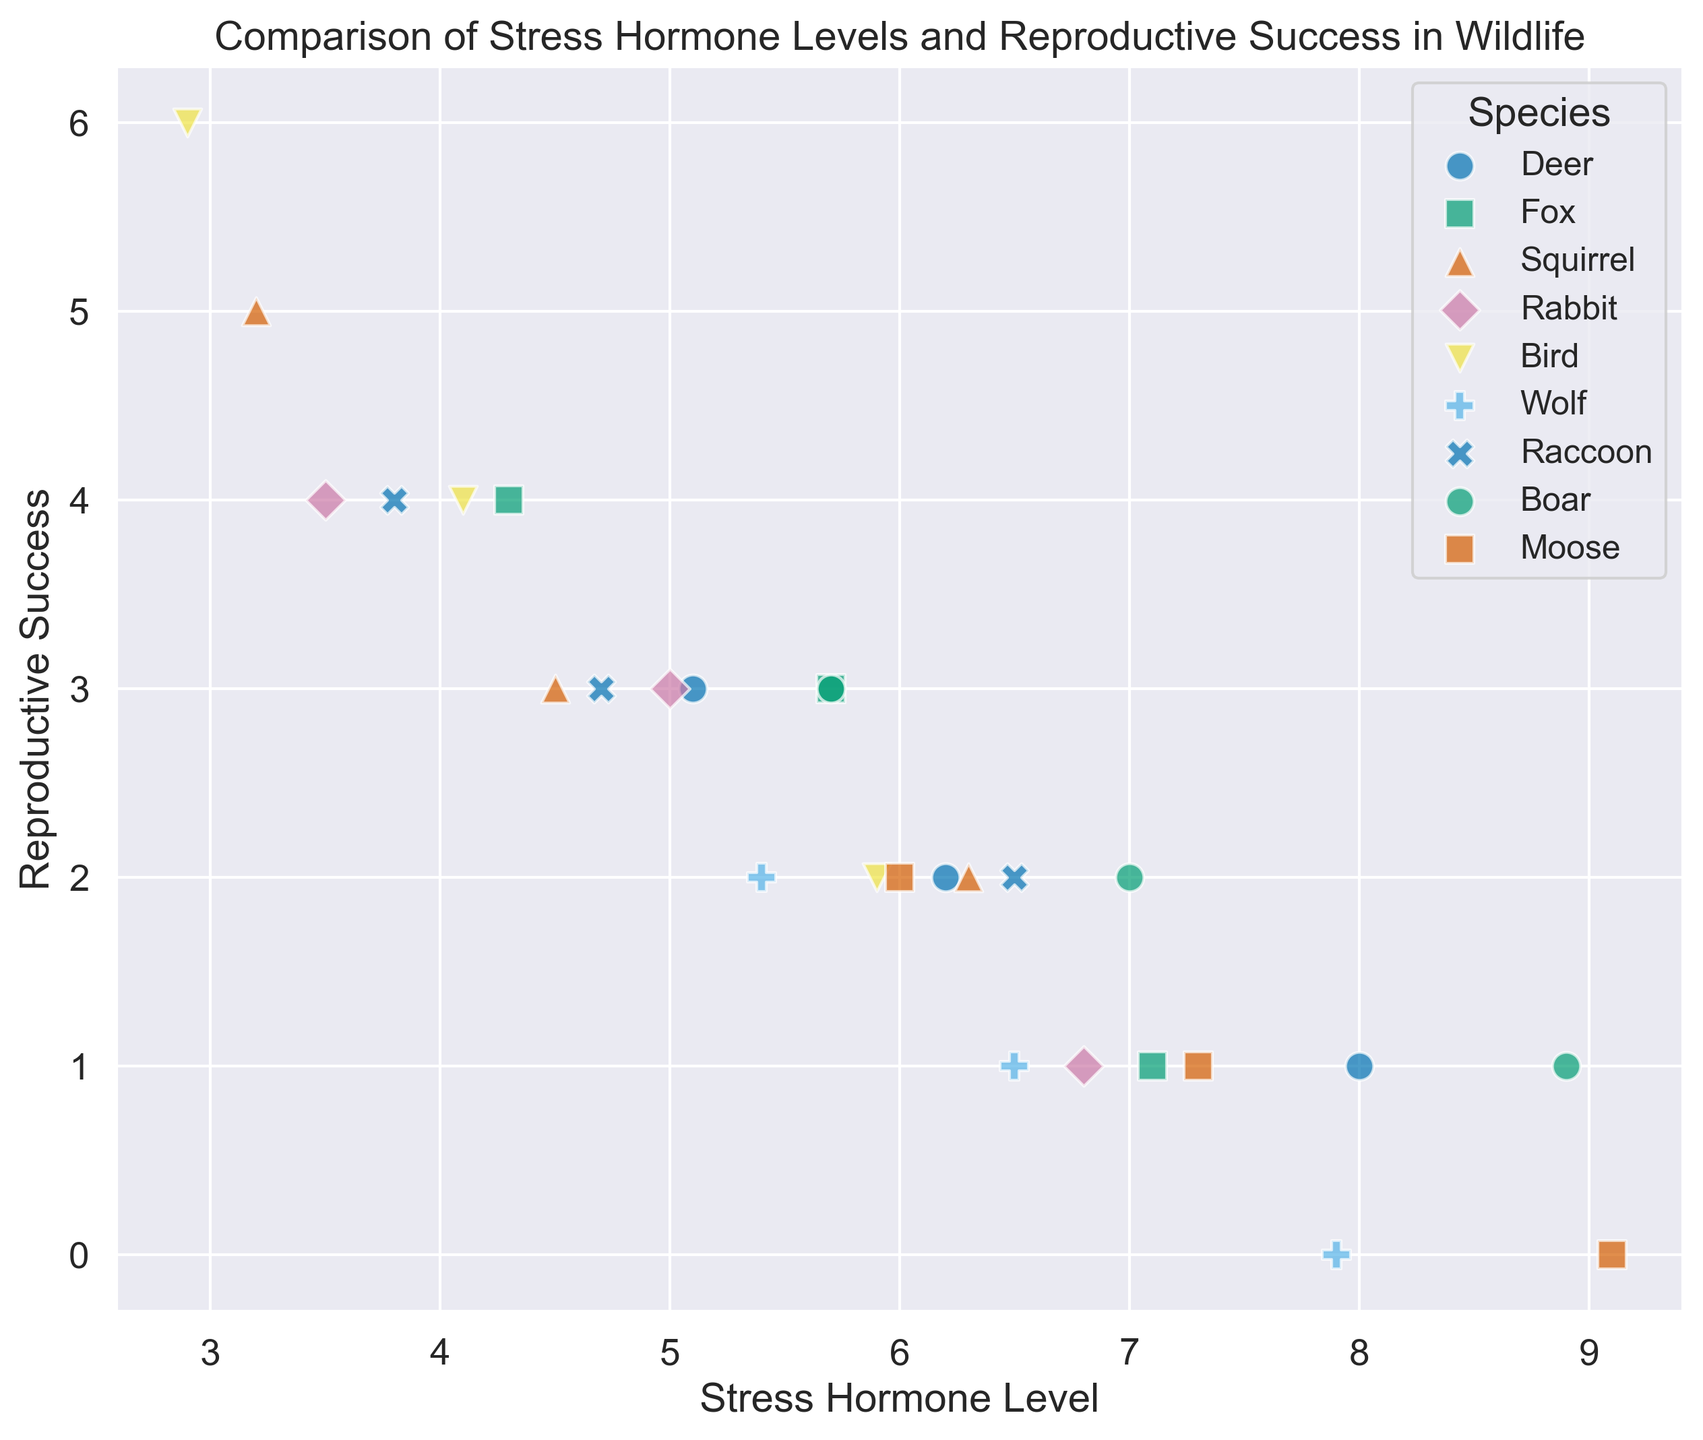What species exhibits the highest stress hormone level at a high human activity level? To find the species with the highest stress hormone level at a high human activity level, observe the scatter points marked for high human activity across different species. The species with the maximum stress hormone level value at this level is Moose with a level of 9.1.
Answer: Moose Which species shows the greatest decrease in reproductive success from low to high human activity levels? To identify the species with the greatest decrease in reproductive success from low to high human activity levels, check for each species the difference in reproductive success between these two conditions. The largest decrease is seen in Wolves, from 2 to 0.
Answer: Wolf What is the average reproductive success for Foxes across all human activity levels? To calculate the average reproductive success for Foxes, sum the reproductive success values for Foxes across low, medium, and high human activity levels and then divide by 3. Foxes have values 4, 3, and 1, so (4+3+1)/3 = 2.67.
Answer: 2.67 For which species is the difference between stress hormone levels at low and high human activity levels the greatest? Calculate the difference in stress hormone levels between low and high human activity levels for each species. Moose shows the largest difference, with stress hormone levels going from 6.0 to 9.1, a difference of 3.1.
Answer: Moose Among Deer, which human activity level corresponds to the lowest reproductive success? Check the reproductive success values for Deer at different human activity levels. The lowest reproductive success for Deer is at high human activity level, with a value of 1.
Answer: High Which species has the least variation in stress hormone levels across different human activity levels? To find the species with the least variation in stress hormone levels, compare the range (difference between maximum and minimum values) of stress hormone levels for each species across different human activity levels. Rabbits show the least variation, with levels ranging from 3.5 to 6.8, a difference of 3.3.
Answer: Rabbit Is there any species for which the reproductive success remains above 1 across all human activity levels? To determine this, observe the reproductive success values for all species at low, medium, and high human activity levels. All species except Wolf and Moose have reproductive success values that remain above 1 across all conditions.
Answer: Yes Which species has the highest reproductive success overall? Review the maximum reproductive success values for all species. Birds exhibit the highest reproductive success with a value of 6 at low human activity level.
Answer: Bird Comparing Birds, Squirrels, and Raccoons, which species has consistently lower stress hormone levels at the same human activity levels? To compare the stress hormone levels at the same human activity levels for Birds, Squirrels, and Raccoons, observe their values at low, medium, and high levels. Birds consistently display the lowest stress hormone levels at corresponding human activity levels, with values 2.9, 4.1, and 5.9.
Answer: Bird 